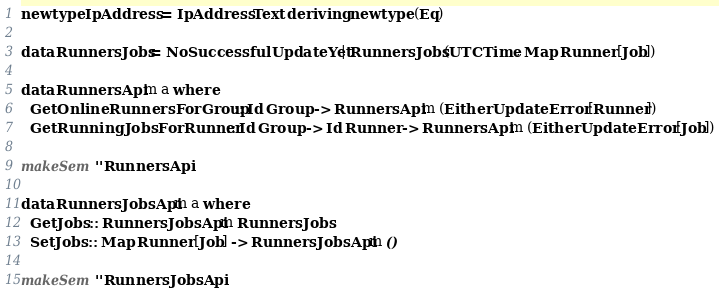<code> <loc_0><loc_0><loc_500><loc_500><_Haskell_>newtype IpAddress = IpAddress Text deriving newtype (Eq)

data RunnersJobs = NoSuccessfulUpdateYet | RunnersJobs (UTCTime, Map Runner [Job])

data RunnersApi m a where
  GetOnlineRunnersForGroup :: Id Group -> RunnersApi m (Either UpdateError [Runner])
  GetRunningJobsForRunner :: Id Group -> Id Runner -> RunnersApi m (Either UpdateError [Job])

makeSem ''RunnersApi

data RunnersJobsApi m a where
  GetJobs :: RunnersJobsApi m RunnersJobs
  SetJobs :: Map Runner [Job] -> RunnersJobsApi m ()

makeSem ''RunnersJobsApi
</code> 